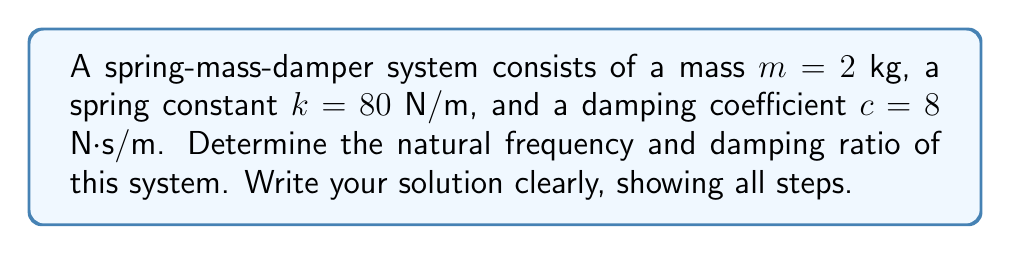Could you help me with this problem? For a spring-mass-damper system, we can determine the natural frequency and damping ratio using the following steps:

1. Natural Frequency:
   The natural frequency (ω_n) is given by the formula:
   
   $$\omega_n = \sqrt{\frac{k}{m}}$$
   
   where $k$ is the spring constant and $m$ is the mass.

   Substituting the given values:
   $$\omega_n = \sqrt{\frac{80 \text{ N/m}}{2 \text{ kg}}} = \sqrt{40} = 6.32 \text{ rad/s}$$

2. Damping Ratio:
   The damping ratio (ζ) is calculated using:
   
   $$\zeta = \frac{c}{2\sqrt{km}}$$
   
   where $c$ is the damping coefficient, $k$ is the spring constant, and $m$ is the mass.

   Substituting the given values:
   $$\zeta = \frac{8 \text{ N·s/m}}{2\sqrt{80 \text{ N/m} \cdot 2 \text{ kg}}} = \frac{8}{2\sqrt{160}} = \frac{8}{2 \cdot 12.65} = 0.316$$

Therefore, the natural frequency is 6.32 rad/s and the damping ratio is 0.316.
Answer: Natural frequency: $\omega_n = 6.32 \text{ rad/s}$
Damping ratio: $\zeta = 0.316$ 